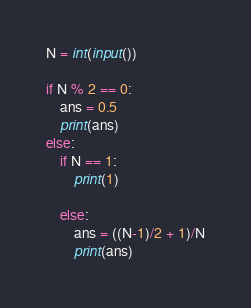Convert code to text. <code><loc_0><loc_0><loc_500><loc_500><_Python_>N = int(input())

if N % 2 == 0:
    ans = 0.5 
    print(ans)
else:
    if N == 1:
        print(1)

    else:
        ans = ((N-1)/2 + 1)/N
        print(ans)</code> 